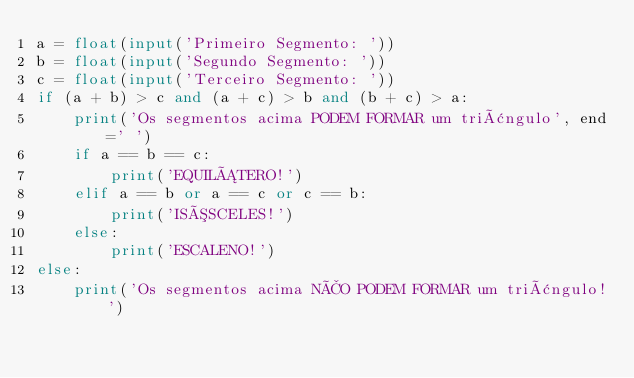<code> <loc_0><loc_0><loc_500><loc_500><_Python_>a = float(input('Primeiro Segmento: '))
b = float(input('Segundo Segmento: '))
c = float(input('Terceiro Segmento: '))
if (a + b) > c and (a + c) > b and (b + c) > a:
    print('Os segmentos acima PODEM FORMAR um triângulo', end=' ')
    if a == b == c:
        print('EQUILÁTERO!')
    elif a == b or a == c or c == b:
        print('ISÓSCELES!')
    else:
        print('ESCALENO!')
else:
    print('Os segmentos acima NÃO PODEM FORMAR um triângulo!')
</code> 